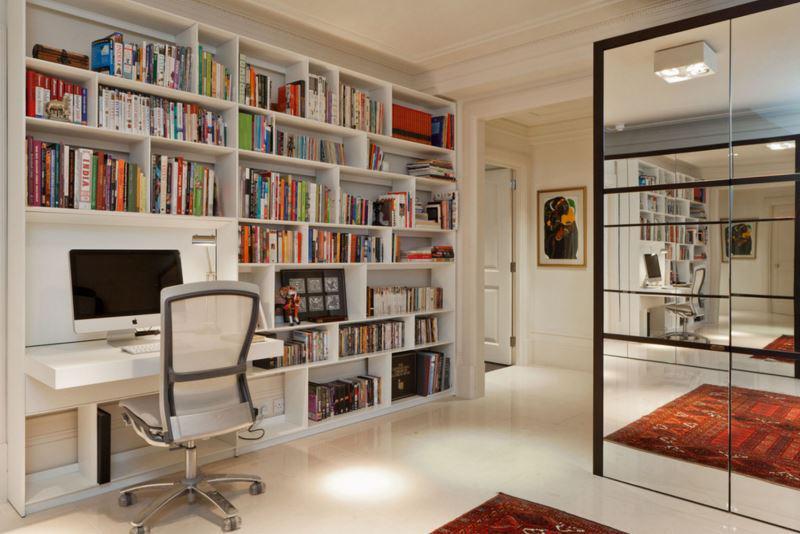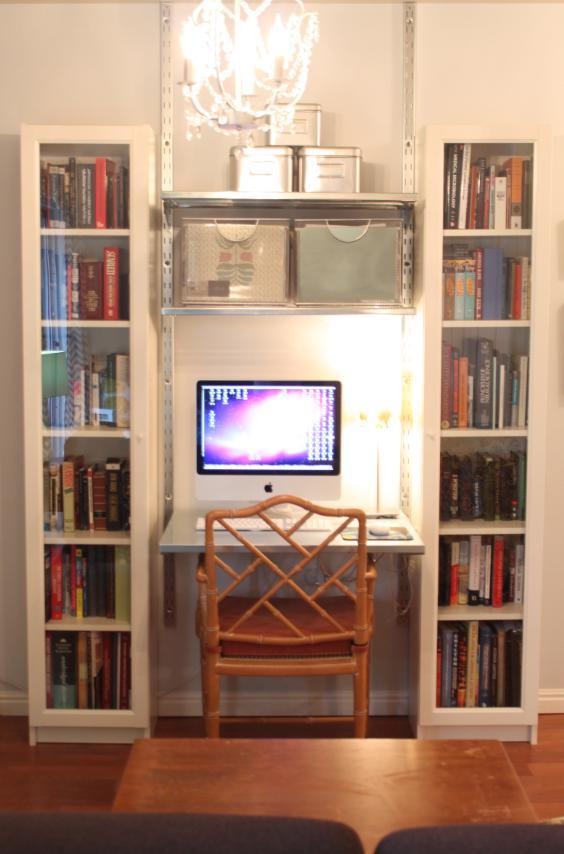The first image is the image on the left, the second image is the image on the right. Examine the images to the left and right. Is the description "In one image a white desk and shelf unit has one narrow end against a wall, while the other image is a white shelf unit flush to the wall with a chair in front of it." accurate? Answer yes or no. No. 